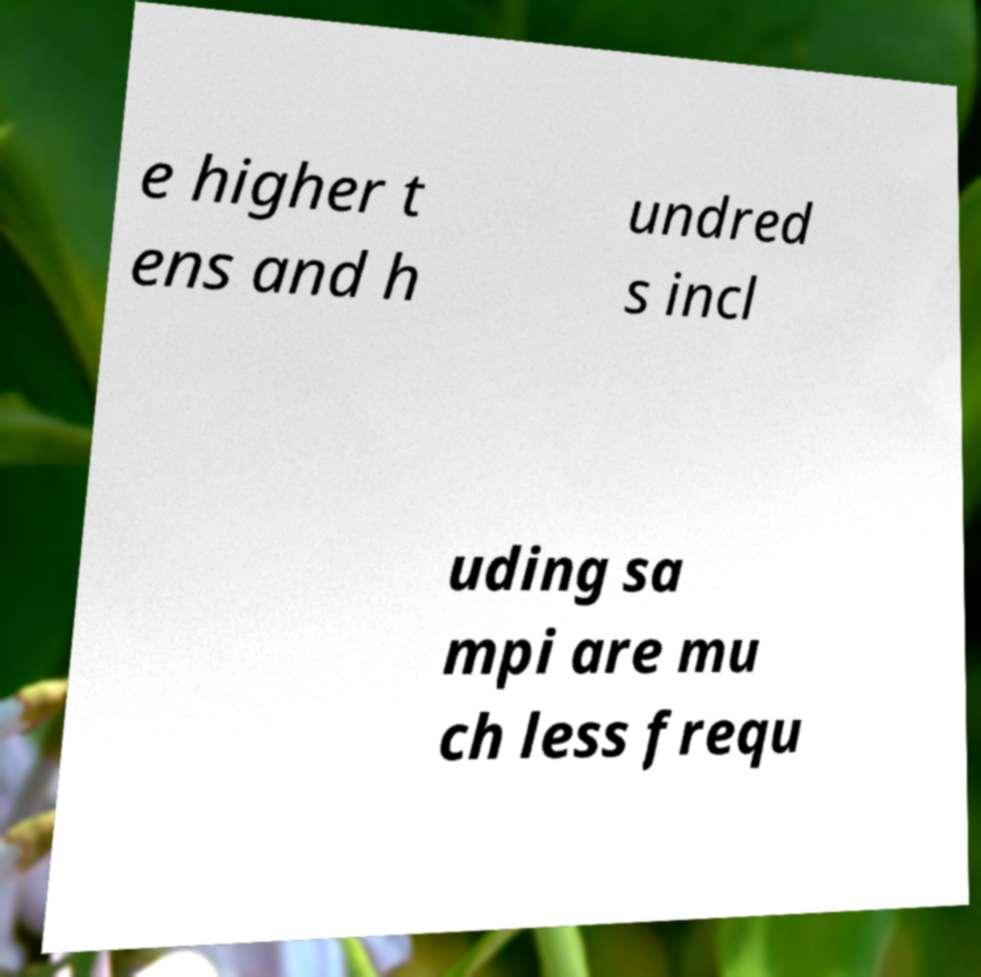For documentation purposes, I need the text within this image transcribed. Could you provide that? e higher t ens and h undred s incl uding sa mpi are mu ch less frequ 